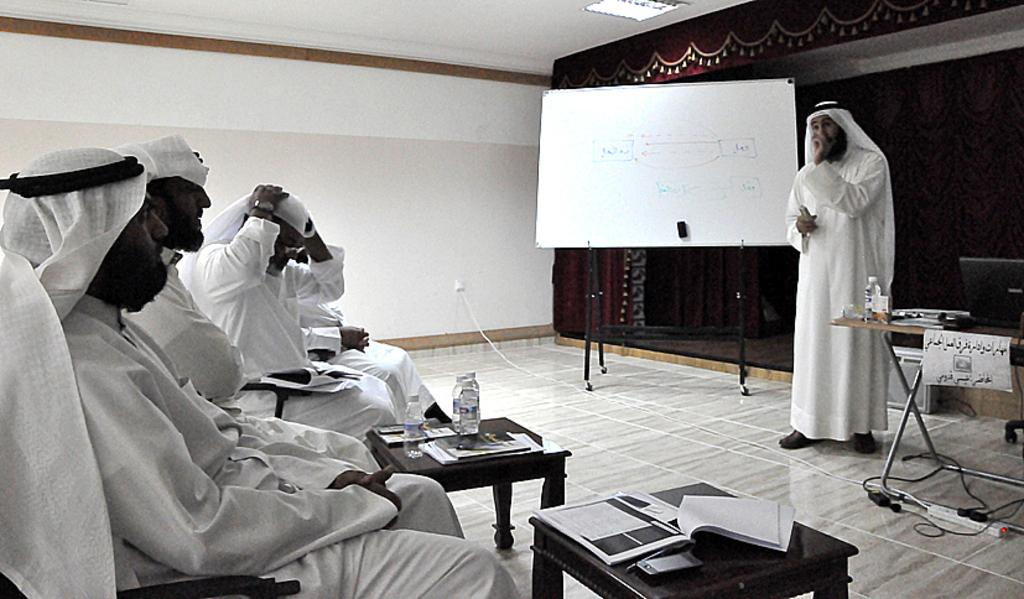What is the color of the wall in the image? The wall in the image is white. What object can be seen on the wall? There is a board on the wall in the image. What are the people in the image doing? The people in the image are sitting on chairs. What is on the table in the image? There are books and a bottle on the table in the image. In which direction is the vessel sailing in the image? There is no vessel present in the image. What is the position of the people in the image? The people in the image are sitting on chairs, which indicates their position relative to the table and board. 